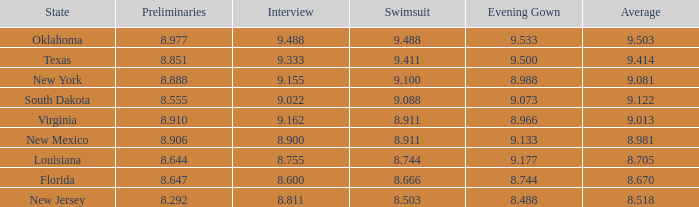What is the starting point when the formal gown is 8.888. 